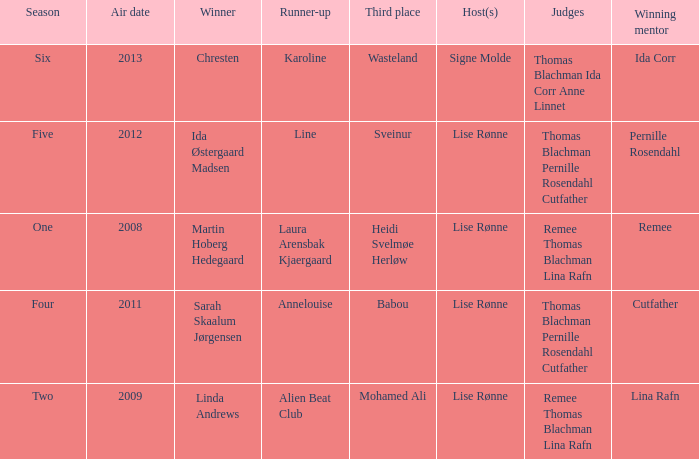Parse the table in full. {'header': ['Season', 'Air date', 'Winner', 'Runner-up', 'Third place', 'Host(s)', 'Judges', 'Winning mentor'], 'rows': [['Six', '2013', 'Chresten', 'Karoline', 'Wasteland', 'Signe Molde', 'Thomas Blachman Ida Corr Anne Linnet', 'Ida Corr'], ['Five', '2012', 'Ida Østergaard Madsen', 'Line', 'Sveinur', 'Lise Rønne', 'Thomas Blachman Pernille Rosendahl Cutfather', 'Pernille Rosendahl'], ['One', '2008', 'Martin Hoberg Hedegaard', 'Laura Arensbak Kjaergaard', 'Heidi Svelmøe Herløw', 'Lise Rønne', 'Remee Thomas Blachman Lina Rafn', 'Remee'], ['Four', '2011', 'Sarah Skaalum Jørgensen', 'Annelouise', 'Babou', 'Lise Rønne', 'Thomas Blachman Pernille Rosendahl Cutfather', 'Cutfather'], ['Two', '2009', 'Linda Andrews', 'Alien Beat Club', 'Mohamed Ali', 'Lise Rønne', 'Remee Thomas Blachman Lina Rafn', 'Lina Rafn']]} Who won third place in season four? Babou. 